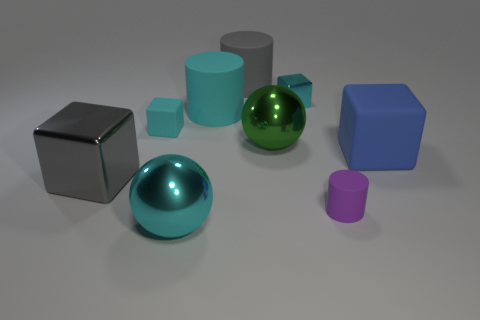Is there any other thing that is the same shape as the large cyan matte thing? Yes, there is a smaller object that shares the cylindrical shape with the large cyan matte one; it is the smaller, magenta-colored cylinder. 